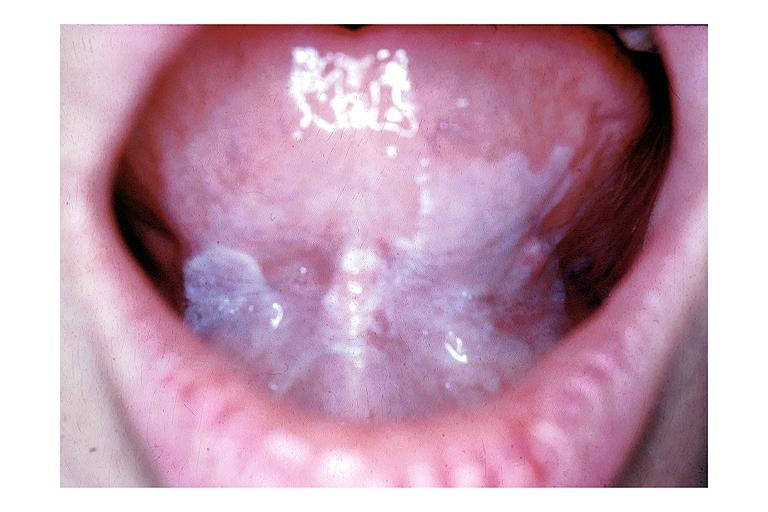does this image show leukoplakia?
Answer the question using a single word or phrase. Yes 